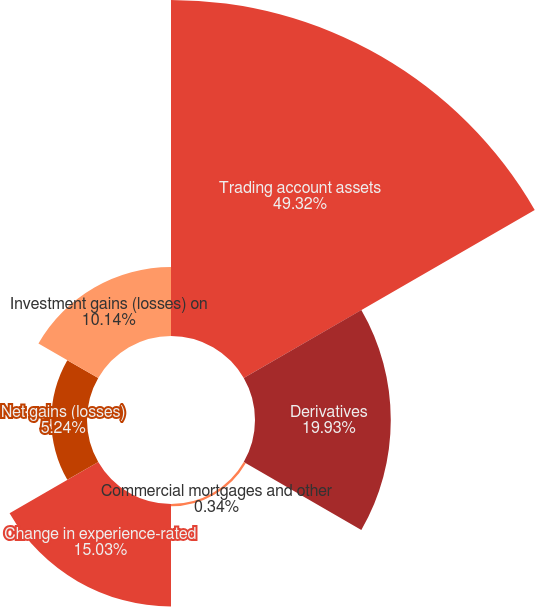Convert chart. <chart><loc_0><loc_0><loc_500><loc_500><pie_chart><fcel>Trading account assets<fcel>Derivatives<fcel>Commercial mortgages and other<fcel>Change in experience-rated<fcel>Net gains (losses)<fcel>Investment gains (losses) on<nl><fcel>49.32%<fcel>19.93%<fcel>0.34%<fcel>15.03%<fcel>5.24%<fcel>10.14%<nl></chart> 